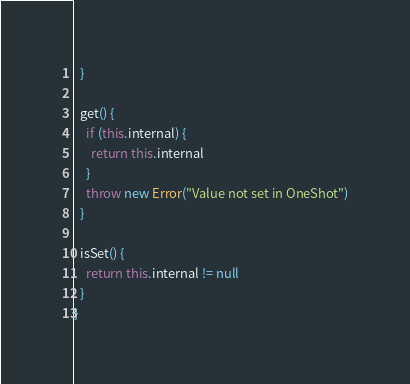Convert code to text. <code><loc_0><loc_0><loc_500><loc_500><_TypeScript_>  }

  get() {
    if (this.internal) {
      return this.internal
    }
    throw new Error("Value not set in OneShot")
  }

  isSet() {
    return this.internal != null
  }
}
</code> 